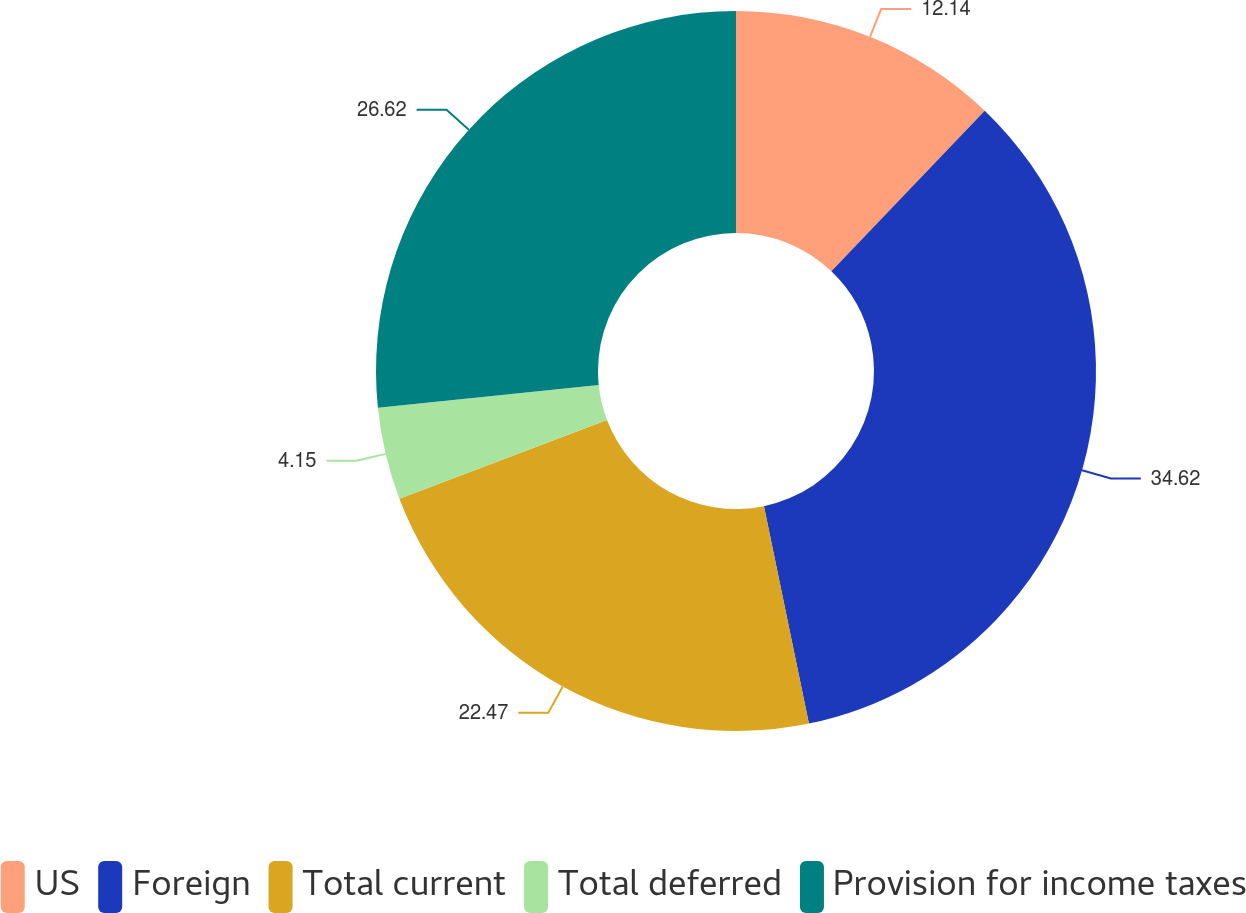Convert chart. <chart><loc_0><loc_0><loc_500><loc_500><pie_chart><fcel>US<fcel>Foreign<fcel>Total current<fcel>Total deferred<fcel>Provision for income taxes<nl><fcel>12.14%<fcel>34.61%<fcel>22.47%<fcel>4.15%<fcel>26.62%<nl></chart> 